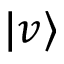<formula> <loc_0><loc_0><loc_500><loc_500>| v \rangle</formula> 